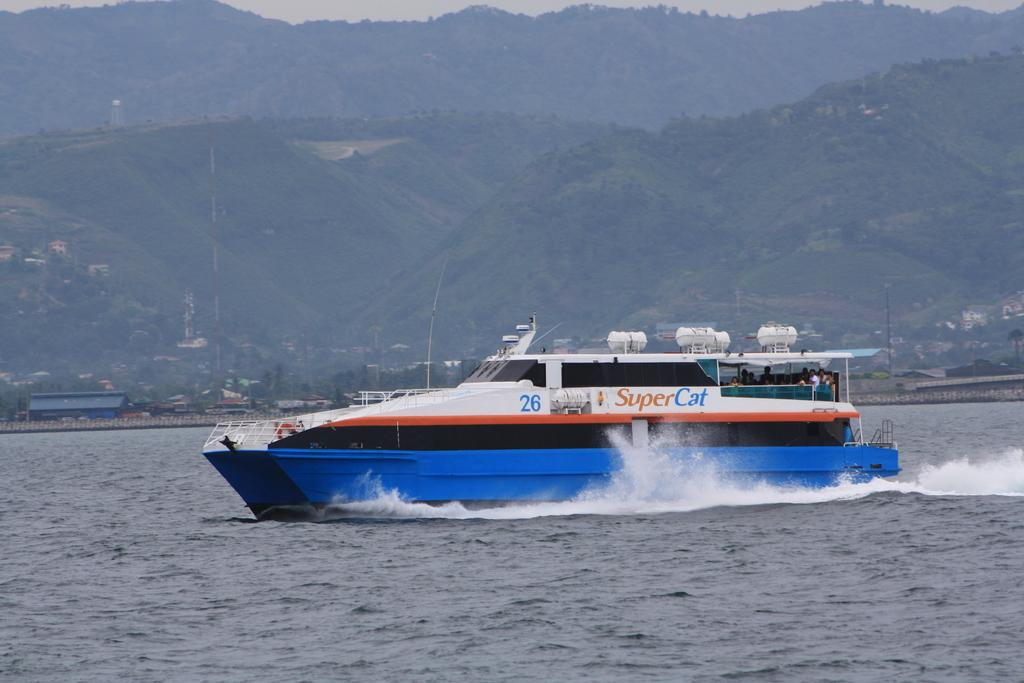What is at the bottom of the image? There is water at the bottom of the image. What is in the water? There is a boat in the water. What can be seen in the distance in the image? There are houses, trees, and hills visible in the background of the image. Who is in the boat? There are people in the boat. What type of coach can be seen in the mouth of the person in the boat? There is no coach or person in the boat's mouth present in the image. 